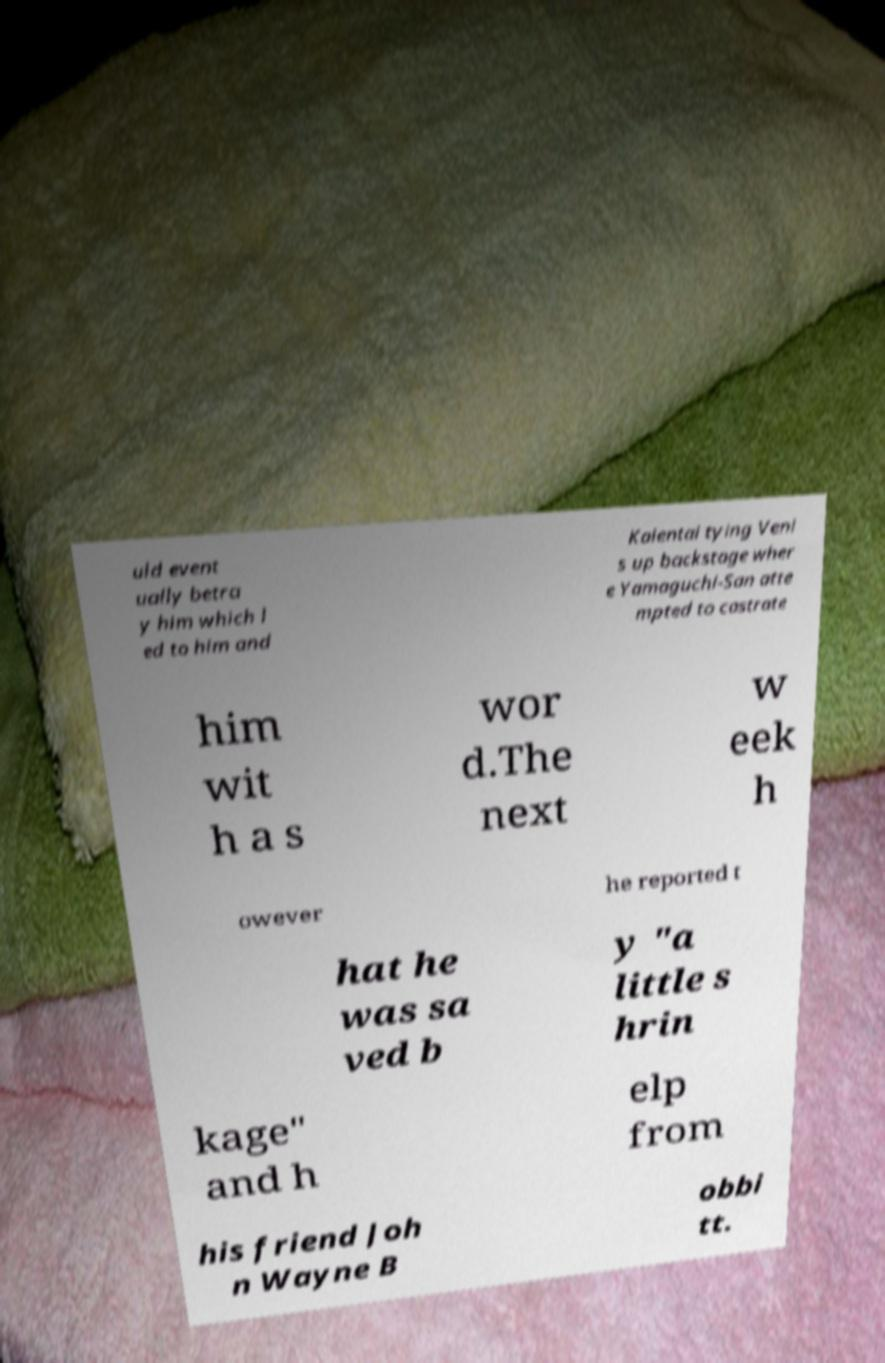Could you extract and type out the text from this image? uld event ually betra y him which l ed to him and Kaientai tying Veni s up backstage wher e Yamaguchi-San atte mpted to castrate him wit h a s wor d.The next w eek h owever he reported t hat he was sa ved b y "a little s hrin kage" and h elp from his friend Joh n Wayne B obbi tt. 